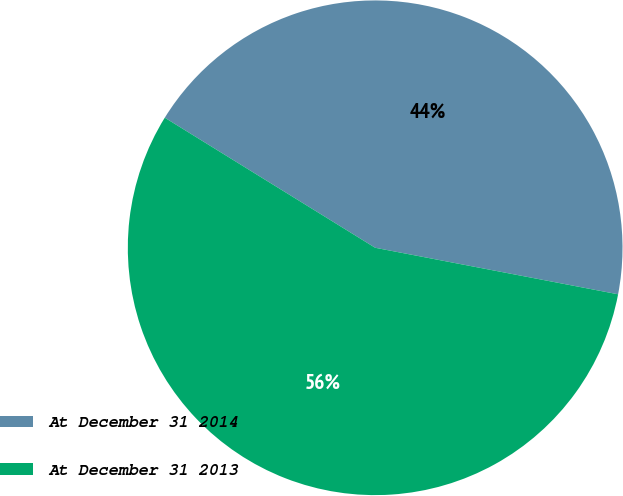Convert chart to OTSL. <chart><loc_0><loc_0><loc_500><loc_500><pie_chart><fcel>At December 31 2014<fcel>At December 31 2013<nl><fcel>44.2%<fcel>55.8%<nl></chart> 